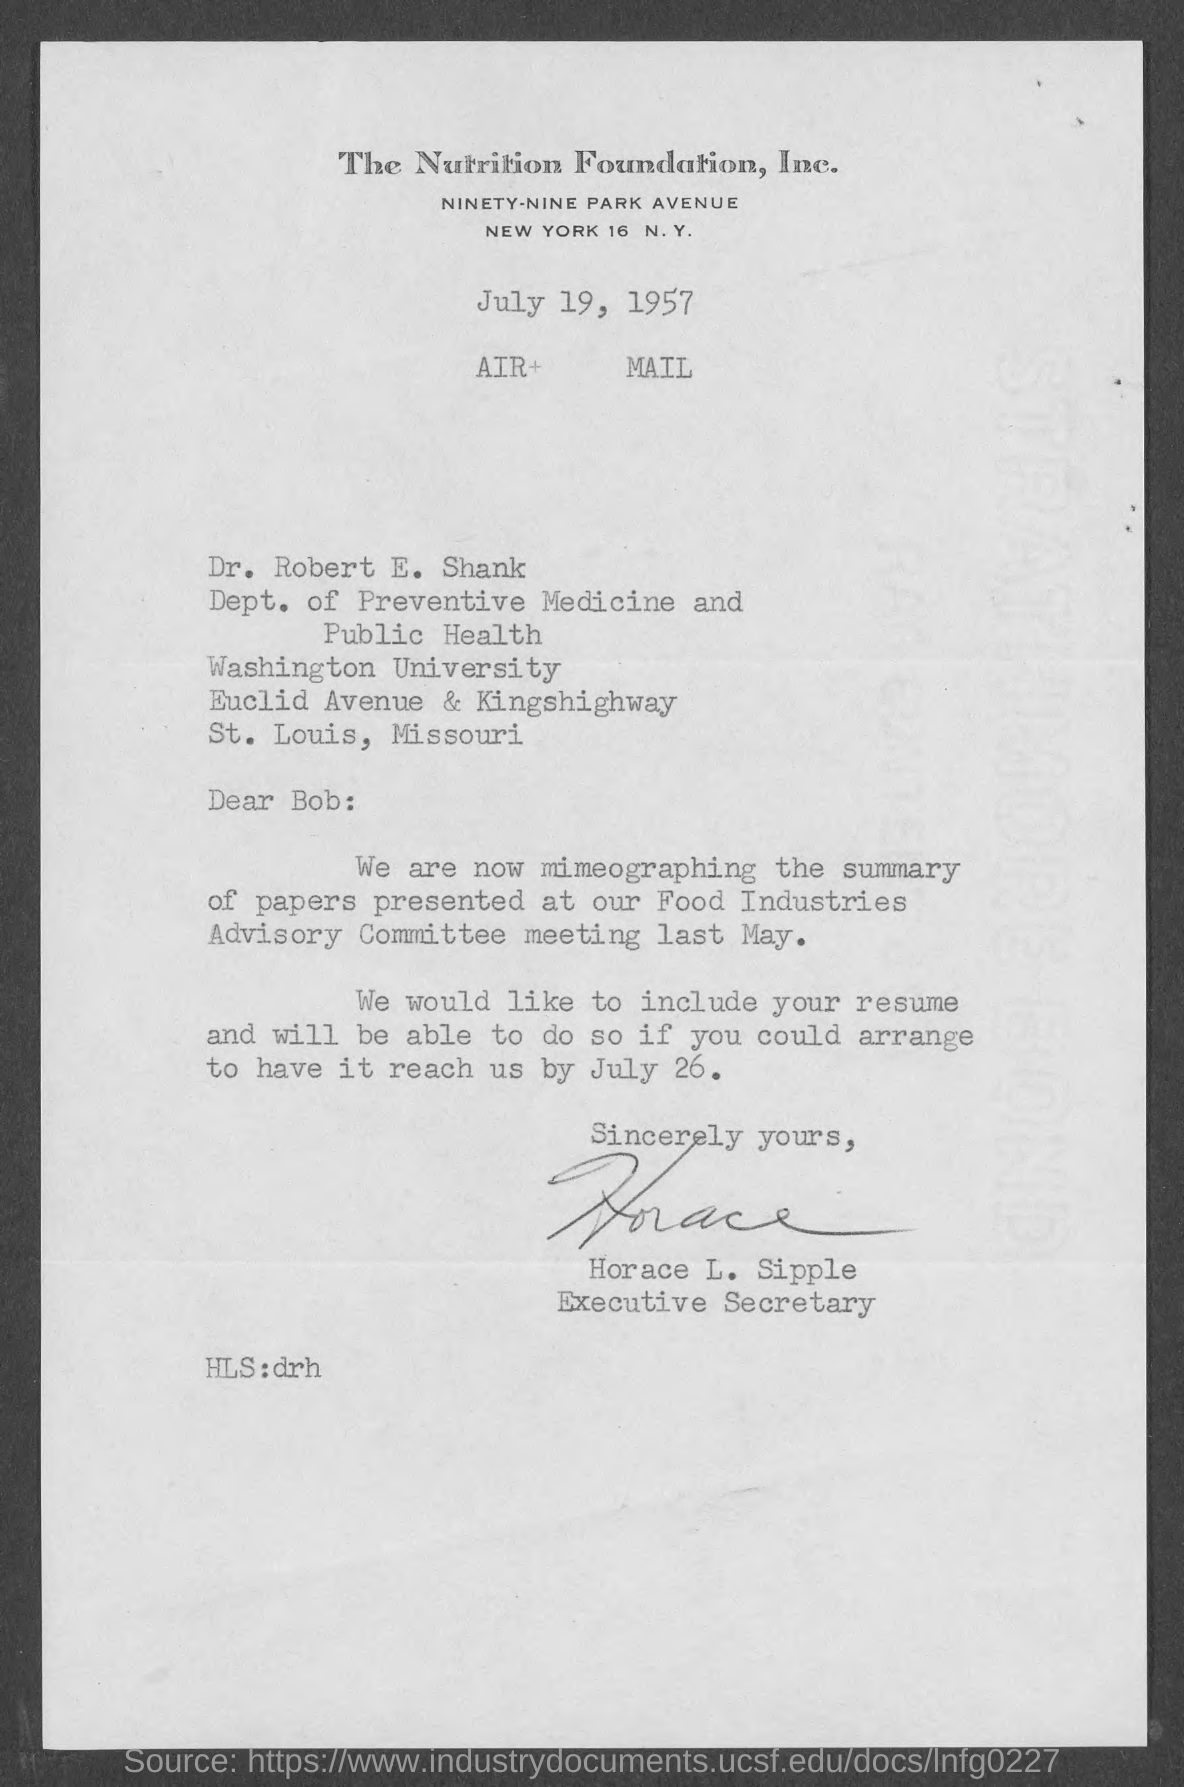Give some essential details in this illustration. Dr. Robert E. Shank is a member of Washington University. Horace L. Sipple's designation is that of an executive secretary. Dr. Robert E. Shank belongs to the Department of Preventive Medicine and Public Health. The sign at the end of the letter belonged to Horace L. Sipple. 